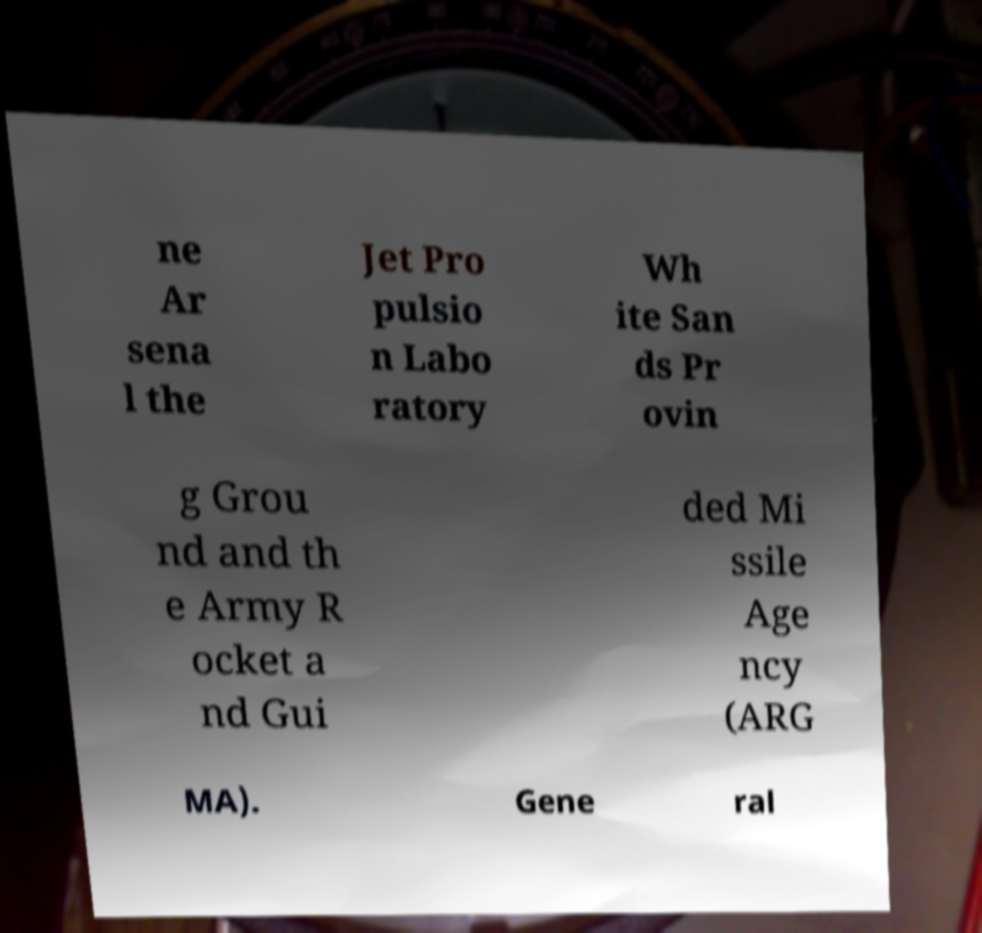For documentation purposes, I need the text within this image transcribed. Could you provide that? ne Ar sena l the Jet Pro pulsio n Labo ratory Wh ite San ds Pr ovin g Grou nd and th e Army R ocket a nd Gui ded Mi ssile Age ncy (ARG MA). Gene ral 